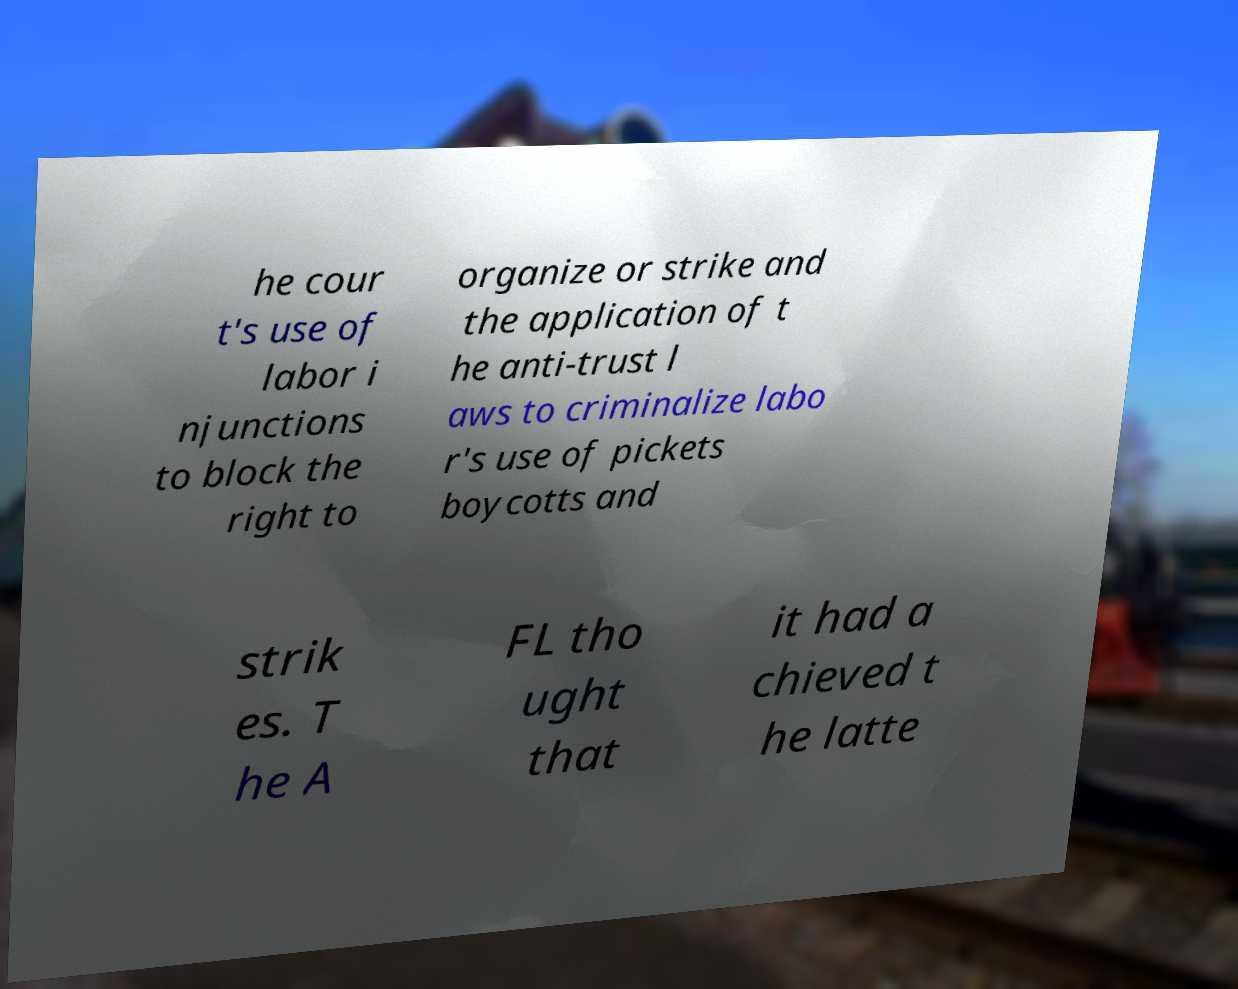Can you accurately transcribe the text from the provided image for me? he cour t's use of labor i njunctions to block the right to organize or strike and the application of t he anti-trust l aws to criminalize labo r's use of pickets boycotts and strik es. T he A FL tho ught that it had a chieved t he latte 